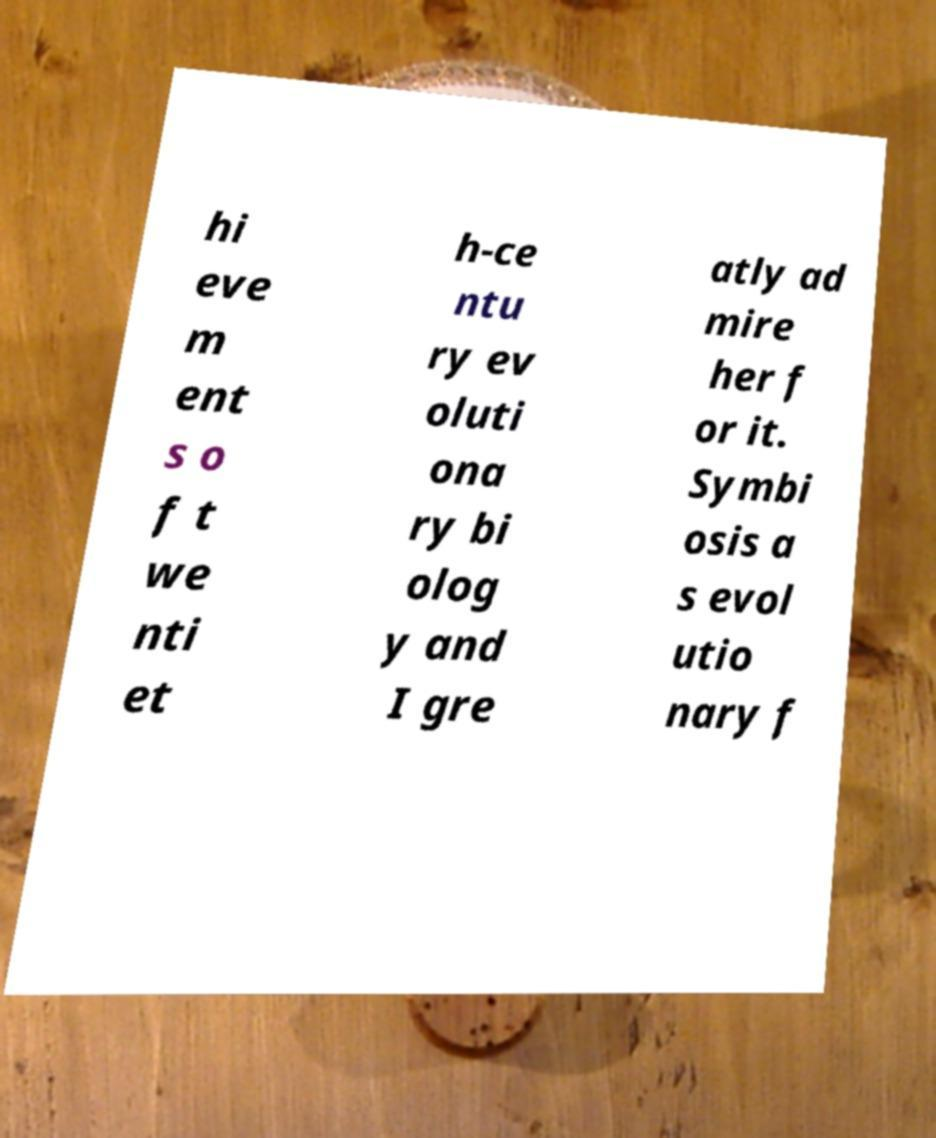Could you assist in decoding the text presented in this image and type it out clearly? hi eve m ent s o f t we nti et h-ce ntu ry ev oluti ona ry bi olog y and I gre atly ad mire her f or it. Symbi osis a s evol utio nary f 